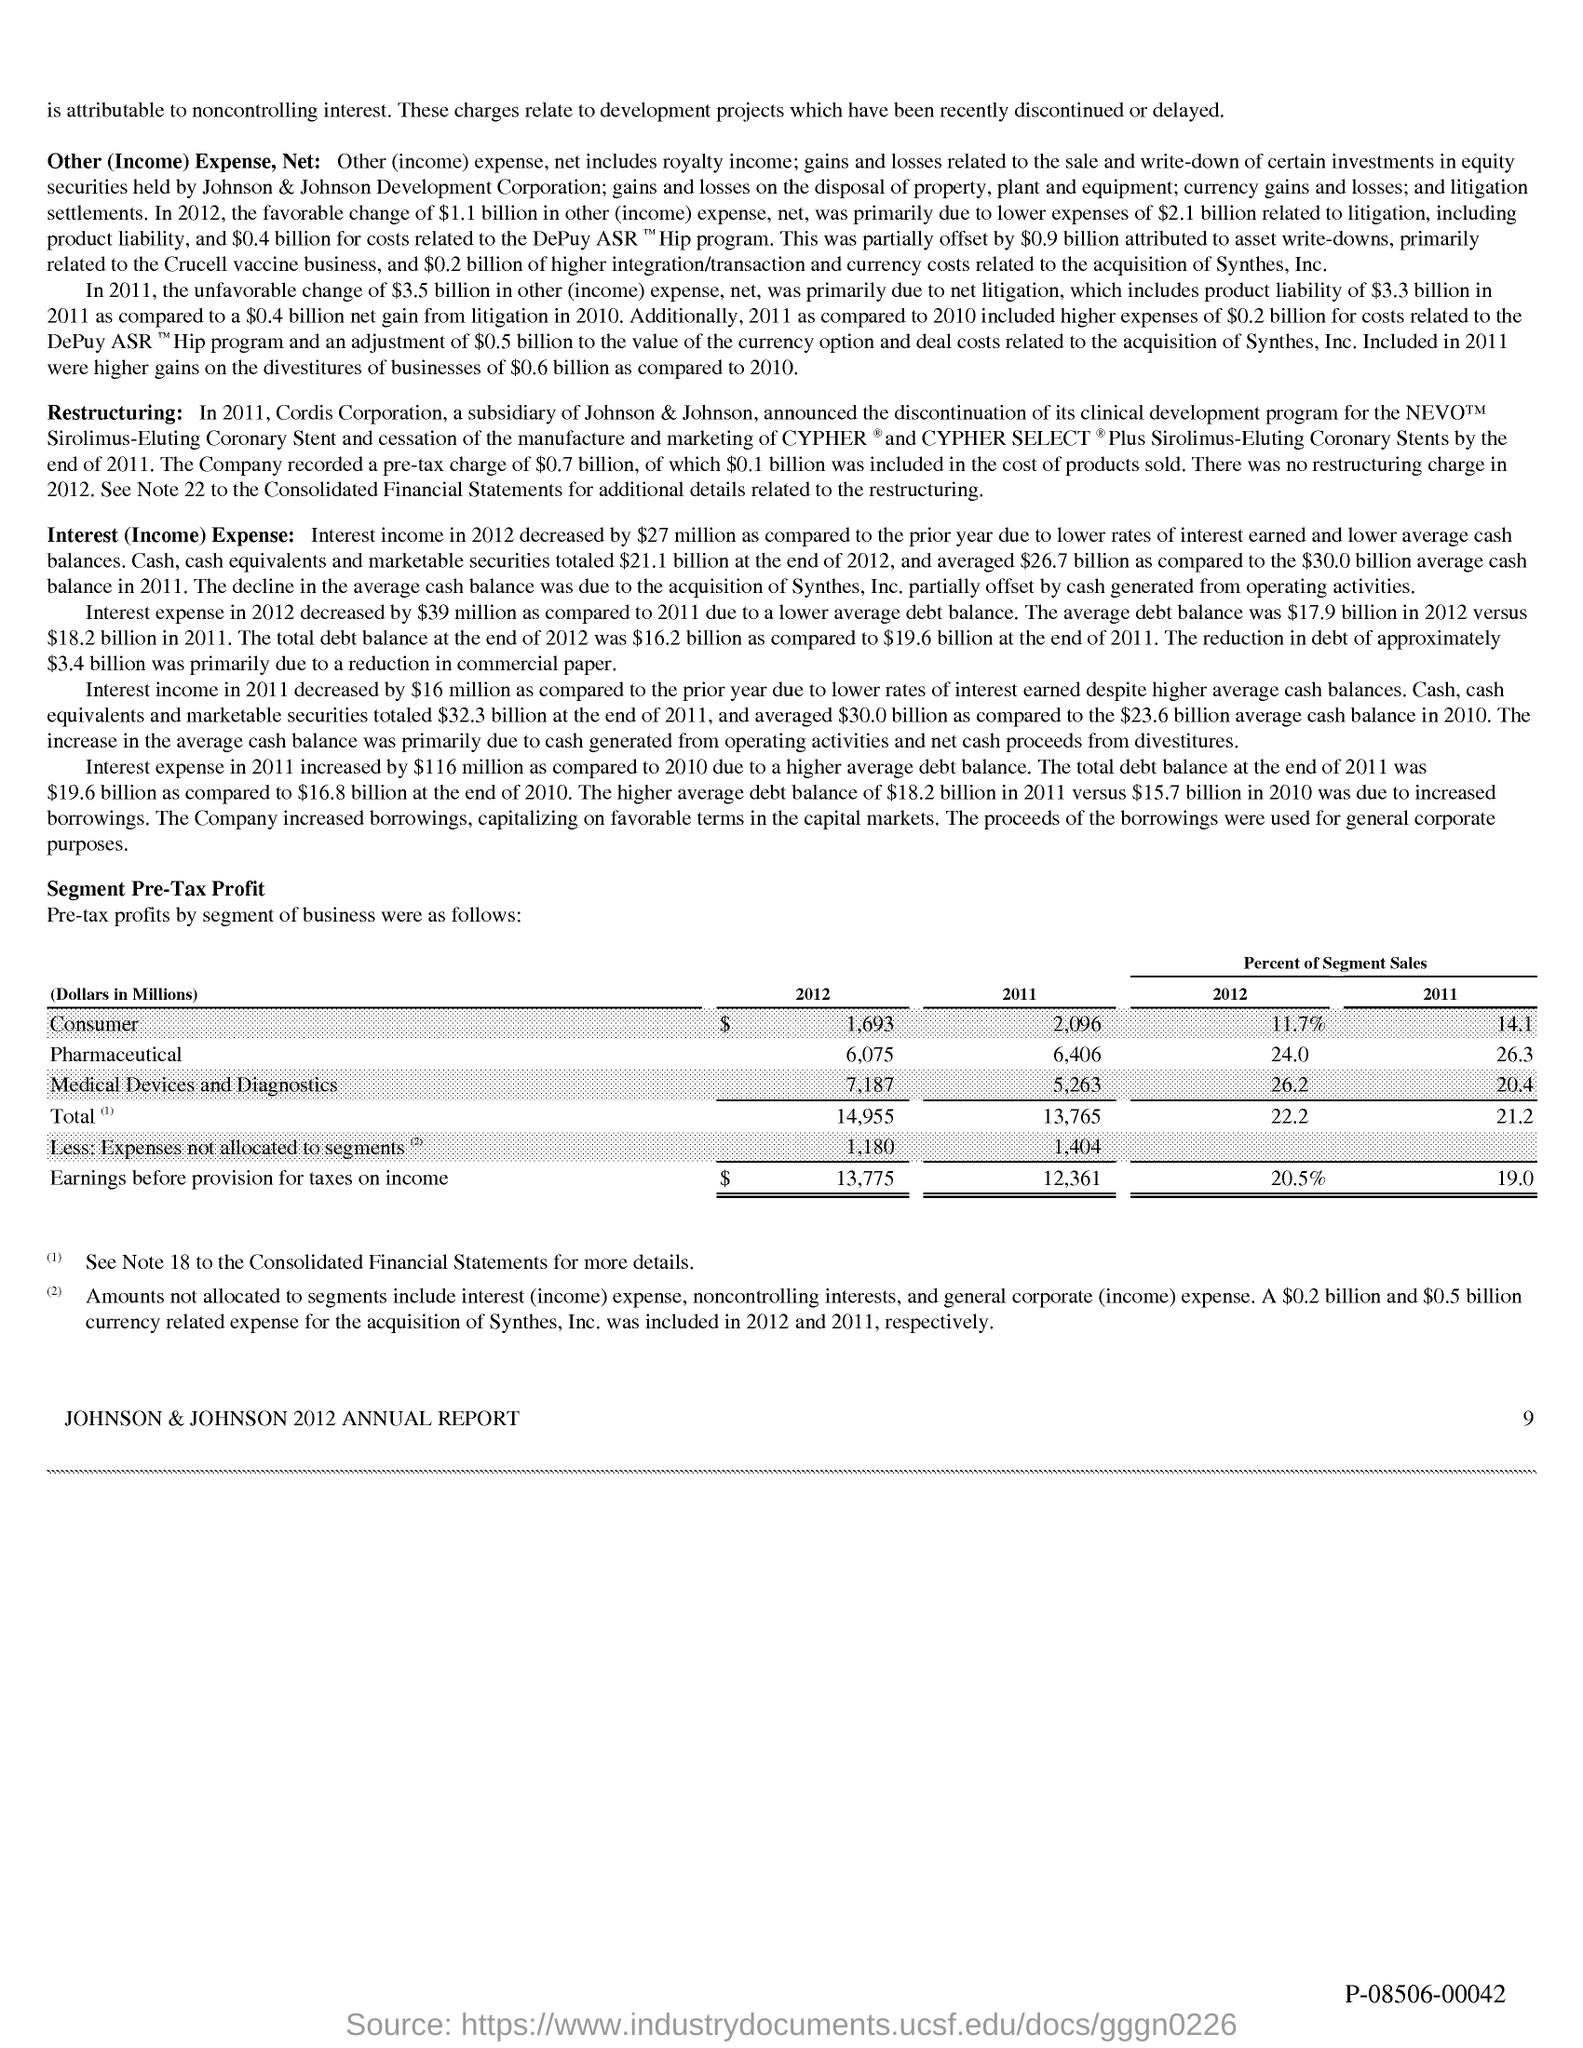What is the Page Number?
Give a very brief answer. 9. 